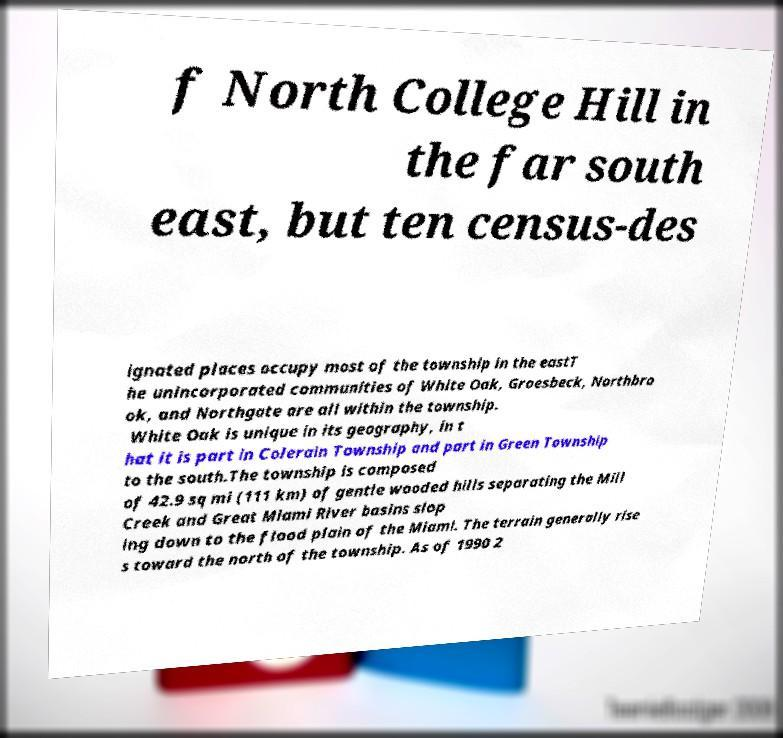Can you read and provide the text displayed in the image?This photo seems to have some interesting text. Can you extract and type it out for me? f North College Hill in the far south east, but ten census-des ignated places occupy most of the township in the eastT he unincorporated communities of White Oak, Groesbeck, Northbro ok, and Northgate are all within the township. White Oak is unique in its geography, in t hat it is part in Colerain Township and part in Green Township to the south.The township is composed of 42.9 sq mi (111 km) of gentle wooded hills separating the Mill Creek and Great Miami River basins slop ing down to the flood plain of the Miami. The terrain generally rise s toward the north of the township. As of 1990 2 